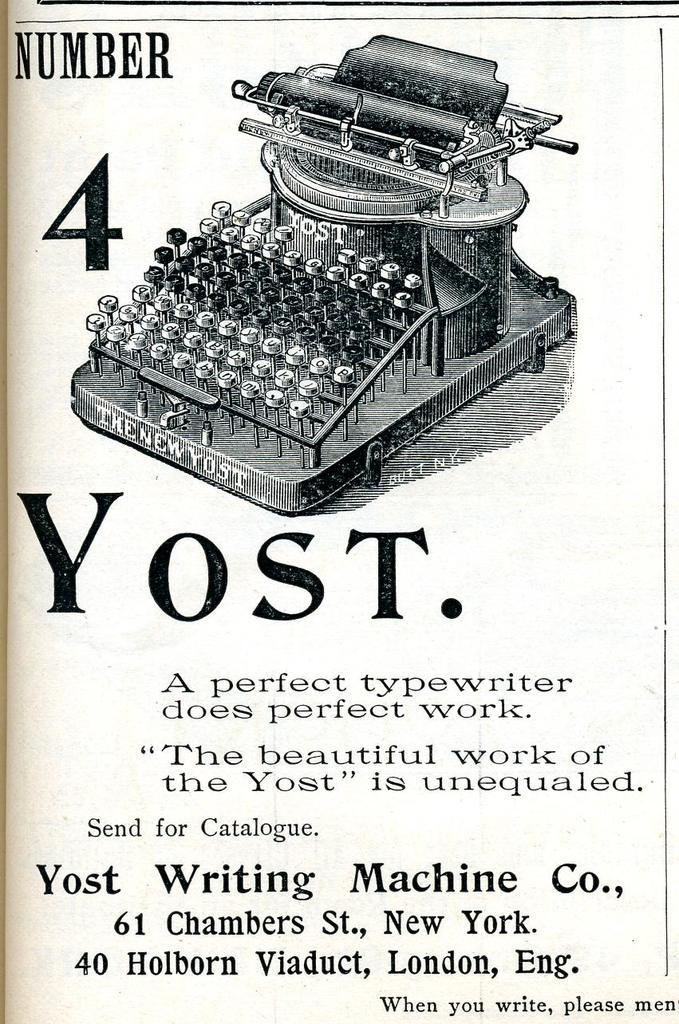<image>
Create a compact narrative representing the image presented. Antique ad for a Number 4 Yost manual typewriter. 